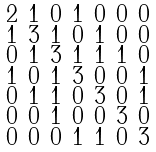Convert formula to latex. <formula><loc_0><loc_0><loc_500><loc_500>\begin{smallmatrix} 2 & 1 & 0 & 1 & 0 & 0 & 0 \\ 1 & 3 & 1 & 0 & 1 & 0 & 0 \\ 0 & 1 & 3 & 1 & 1 & 1 & 0 \\ 1 & 0 & 1 & 3 & 0 & 0 & 1 \\ 0 & 1 & 1 & 0 & 3 & 0 & 1 \\ 0 & 0 & 1 & 0 & 0 & 3 & 0 \\ 0 & 0 & 0 & 1 & 1 & 0 & 3 \end{smallmatrix}</formula> 